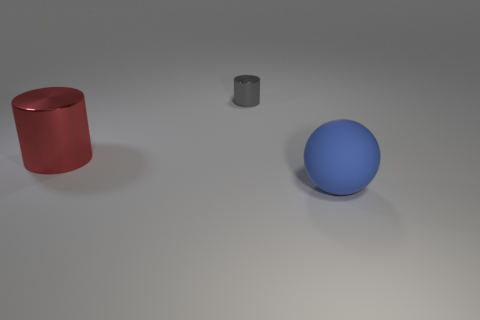Subtract all balls. How many objects are left? 2 Add 1 red metal cylinders. How many red metal cylinders exist? 2 Add 3 blue matte things. How many objects exist? 6 Subtract all red cylinders. How many cylinders are left? 1 Subtract 0 brown cylinders. How many objects are left? 3 Subtract 1 spheres. How many spheres are left? 0 Subtract all yellow cylinders. Subtract all red cubes. How many cylinders are left? 2 Subtract all purple blocks. How many red cylinders are left? 1 Subtract all big shiny cylinders. Subtract all blue balls. How many objects are left? 1 Add 1 red things. How many red things are left? 2 